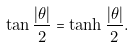<formula> <loc_0><loc_0><loc_500><loc_500>\tan \frac { | \theta | } { 2 } = \tanh \frac { | \theta | } { 2 } .</formula> 